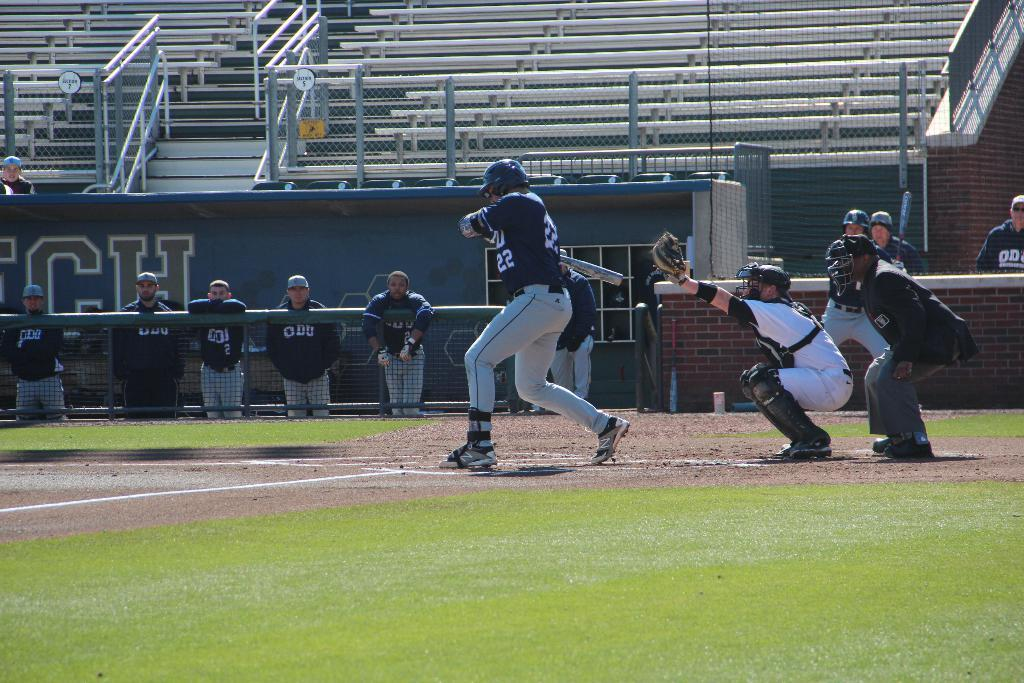<image>
Present a compact description of the photo's key features. Number 22 is up to bat for the ODU team. 